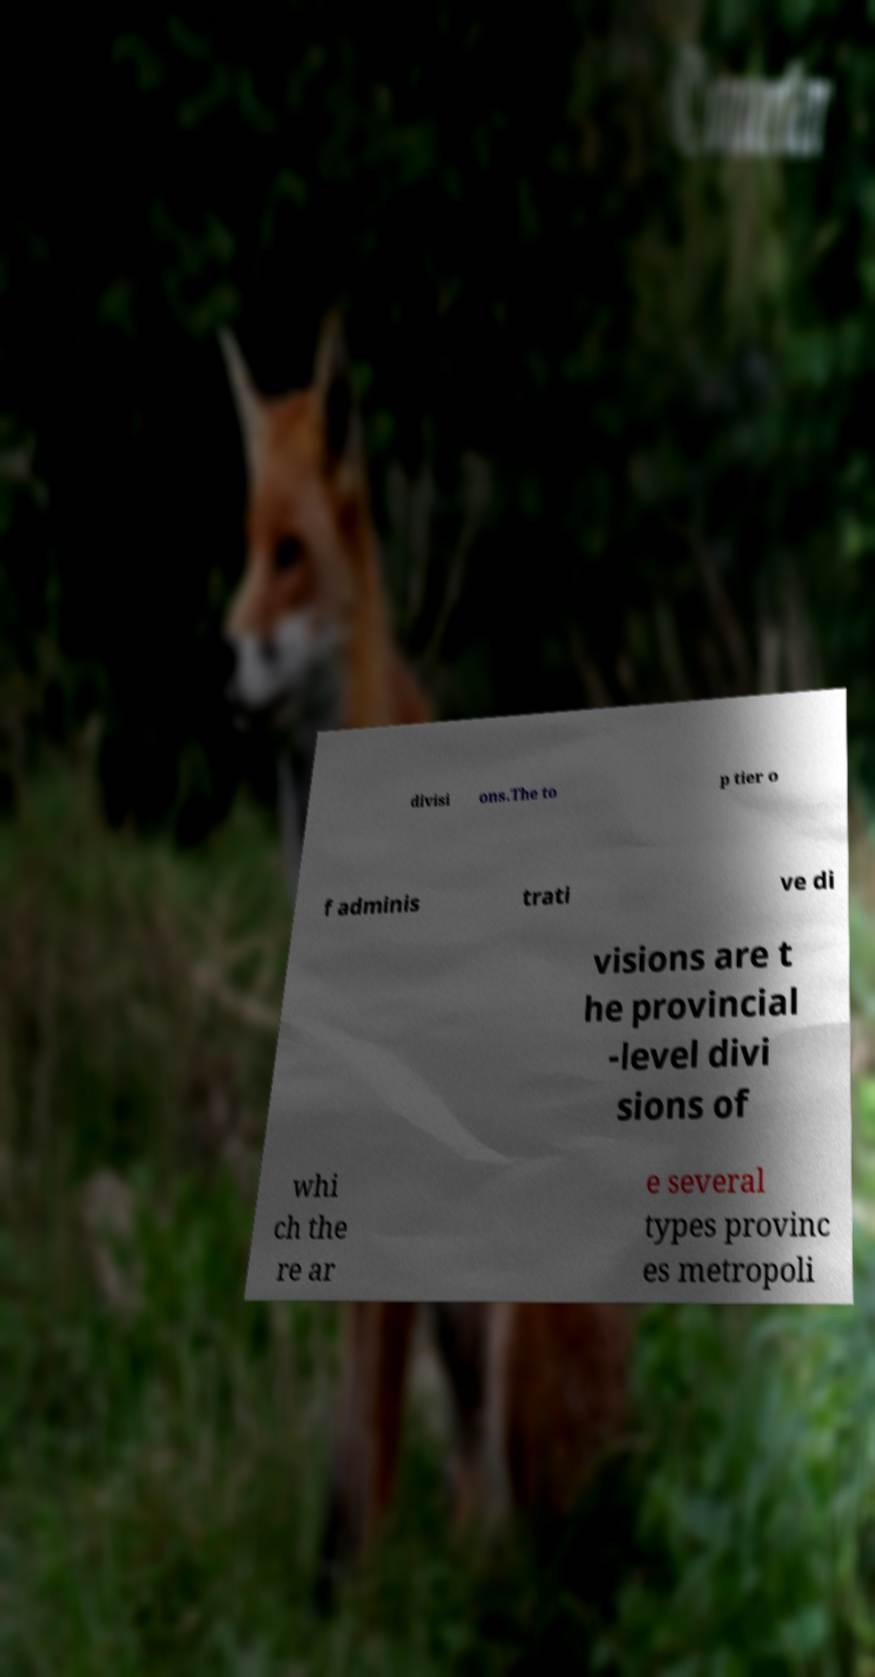What messages or text are displayed in this image? I need them in a readable, typed format. divisi ons.The to p tier o f adminis trati ve di visions are t he provincial -level divi sions of whi ch the re ar e several types provinc es metropoli 